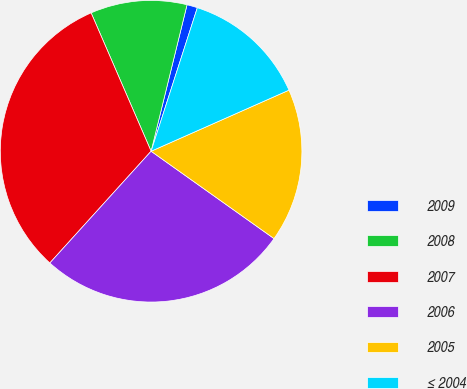Convert chart. <chart><loc_0><loc_0><loc_500><loc_500><pie_chart><fcel>2009<fcel>2008<fcel>2007<fcel>2006<fcel>2005<fcel>≤ 2004<nl><fcel>1.13%<fcel>10.34%<fcel>31.77%<fcel>26.88%<fcel>16.47%<fcel>13.4%<nl></chart> 